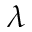Convert formula to latex. <formula><loc_0><loc_0><loc_500><loc_500>\lambda</formula> 